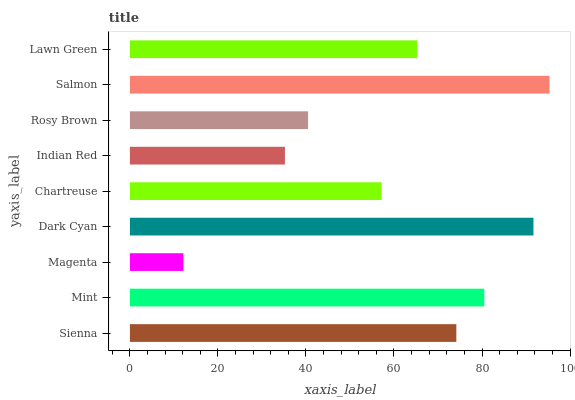Is Magenta the minimum?
Answer yes or no. Yes. Is Salmon the maximum?
Answer yes or no. Yes. Is Mint the minimum?
Answer yes or no. No. Is Mint the maximum?
Answer yes or no. No. Is Mint greater than Sienna?
Answer yes or no. Yes. Is Sienna less than Mint?
Answer yes or no. Yes. Is Sienna greater than Mint?
Answer yes or no. No. Is Mint less than Sienna?
Answer yes or no. No. Is Lawn Green the high median?
Answer yes or no. Yes. Is Lawn Green the low median?
Answer yes or no. Yes. Is Dark Cyan the high median?
Answer yes or no. No. Is Magenta the low median?
Answer yes or no. No. 